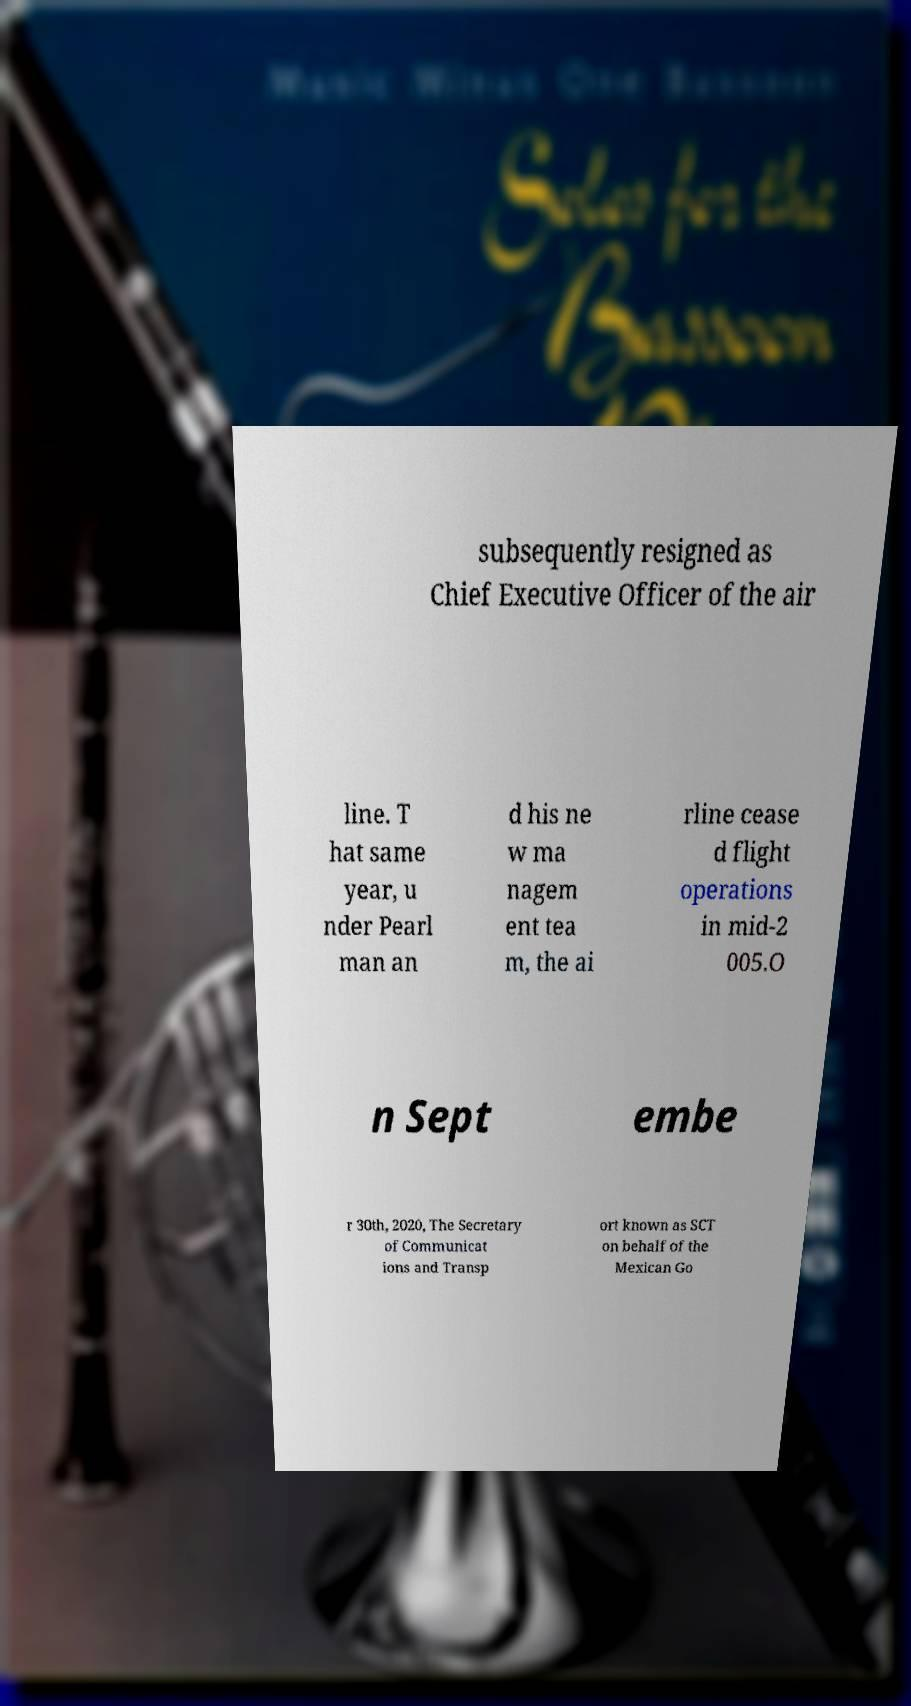Please read and relay the text visible in this image. What does it say? subsequently resigned as Chief Executive Officer of the air line. T hat same year, u nder Pearl man an d his ne w ma nagem ent tea m, the ai rline cease d flight operations in mid-2 005.O n Sept embe r 30th, 2020, The Secretary of Communicat ions and Transp ort known as SCT on behalf of the Mexican Go 